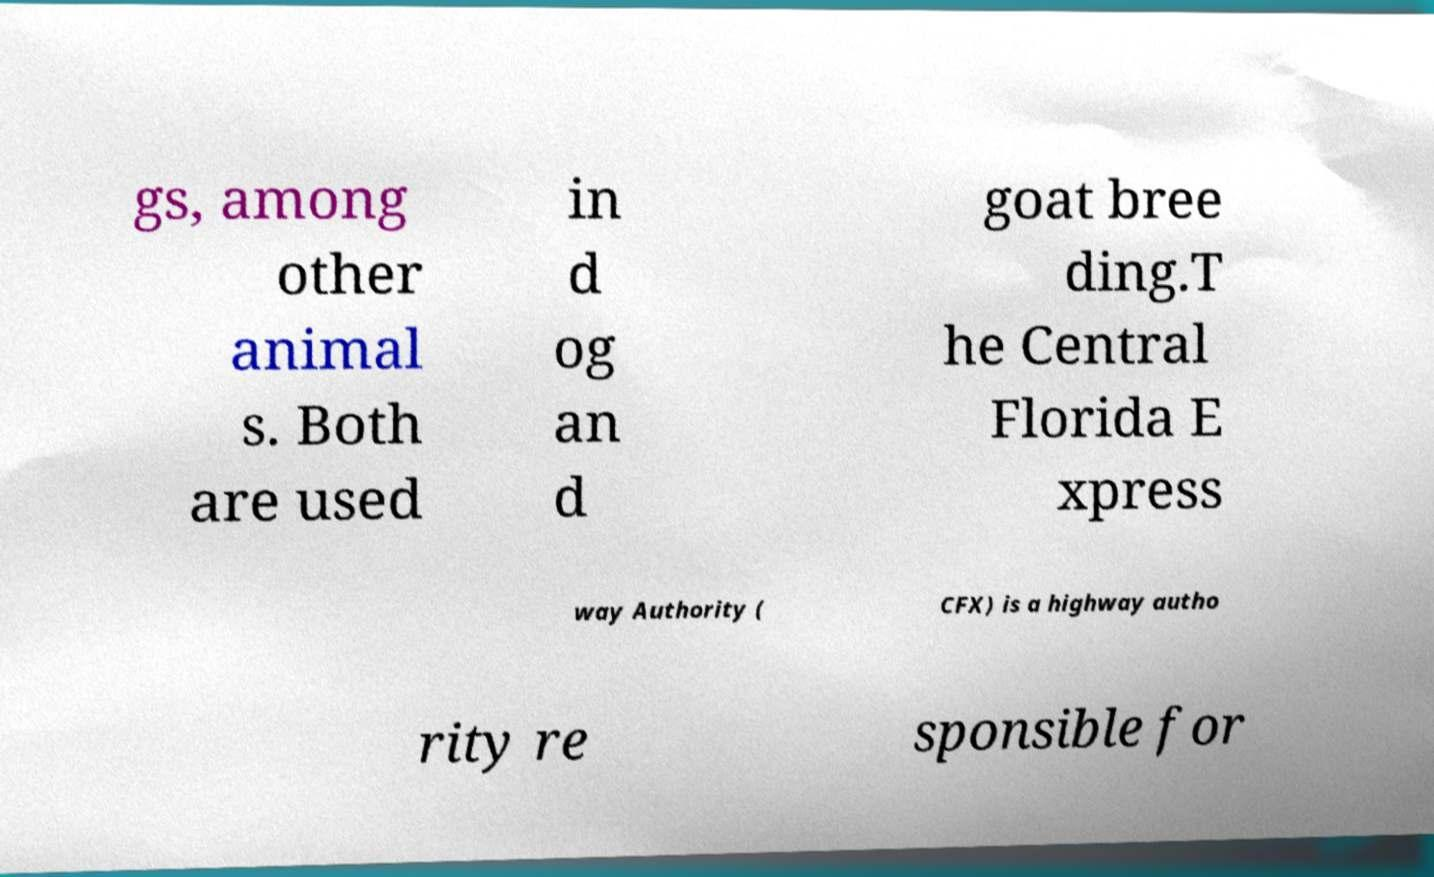Can you accurately transcribe the text from the provided image for me? gs, among other animal s. Both are used in d og an d goat bree ding.T he Central Florida E xpress way Authority ( CFX) is a highway autho rity re sponsible for 